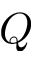<formula> <loc_0><loc_0><loc_500><loc_500>Q</formula> 